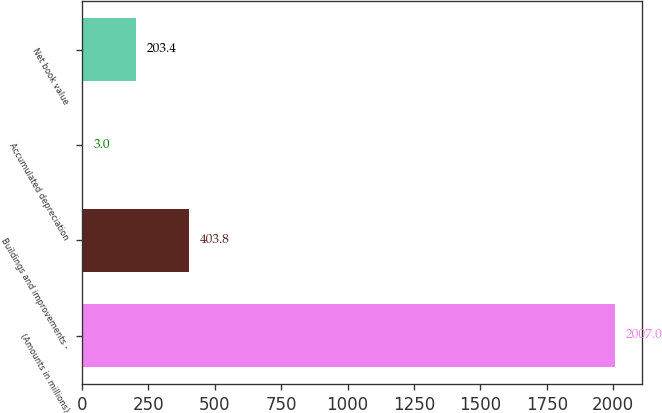Convert chart. <chart><loc_0><loc_0><loc_500><loc_500><bar_chart><fcel>(Amounts in millions)<fcel>Buildings and improvements -<fcel>Accumulated depreciation<fcel>Net book value<nl><fcel>2007<fcel>403.8<fcel>3<fcel>203.4<nl></chart> 